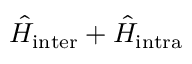Convert formula to latex. <formula><loc_0><loc_0><loc_500><loc_500>\hat { H } _ { i n t e r } + \hat { H } _ { i n t r a }</formula> 